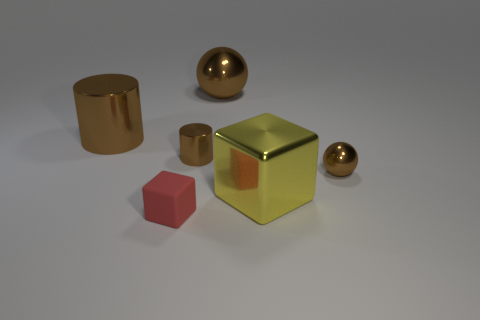What is the shape of the small shiny thing that is the same color as the tiny shiny cylinder?
Give a very brief answer. Sphere. Are any blue metal objects visible?
Make the answer very short. No. Is the shape of the small metal object that is on the right side of the large yellow metal cube the same as the large object that is behind the big brown cylinder?
Keep it short and to the point. Yes. What number of small things are gray cubes or red rubber objects?
Offer a terse response. 1. What shape is the big yellow thing that is made of the same material as the large brown cylinder?
Give a very brief answer. Cube. What is the color of the rubber block?
Offer a very short reply. Red. How many objects are either tiny red matte cubes or brown metallic things?
Your answer should be compact. 5. Is there any other thing that is made of the same material as the small brown cylinder?
Your answer should be compact. Yes. Is the number of brown metal cylinders to the left of the tiny brown cylinder less than the number of brown shiny spheres?
Provide a short and direct response. Yes. Are there more brown balls that are right of the yellow shiny thing than matte objects that are in front of the red block?
Ensure brevity in your answer.  Yes. 